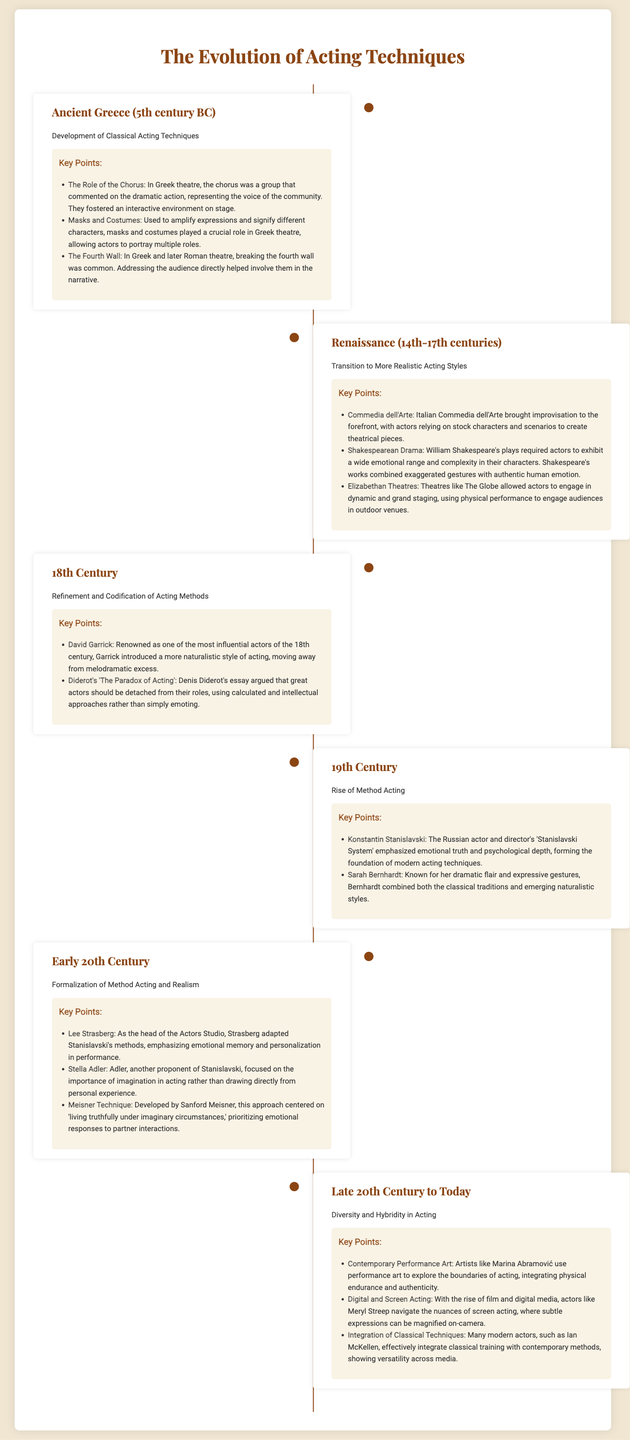What period marks the beginning of Classical Acting Techniques? The document states that Classical Acting Techniques began in Ancient Greece during the 5th century BC.
Answer: 5th century BC Who was a significant figure in the 18th century for introducing a naturalistic acting style? David Garrick is mentioned in the document as one of the most influential actors of the 18th century for his naturalistic style.
Answer: David Garrick Which acting technique focuses on emotional truth and psychological depth? The document identifies the 'Stanislavski System' created by Konstantin Stanislavski as focusing on emotional truth and psychological depth.
Answer: Stanislavski System What decade does the document reference when discussing the rise of Method Acting? The rise of Method Acting is associated with the 19th century in the document.
Answer: 19th century In which division of the timeline is the 'Meisner Technique' mentioned? The 'Meisner Technique' is discussed in the Early 20th Century section of the document.
Answer: Early 20th Century What is the primary characteristic of acting according to Stella Adler? Stella Adler emphasized the importance of imagination in acting, as stated in the document.
Answer: Imagination How does the document describe contemporary performance artists like Marina Abramović? The document describes contemporary performance artists as exploring the boundaries of acting, integrating physical endurance and authenticity.
Answer: Physical endurance and authenticity Which famous actress is noted for navigating the nuances of screen acting? The document highlights Meryl Streep as an example of an actress who navigates screen acting nuances.
Answer: Meryl Streep What term is used to describe the interaction style in Ancient Greece theatre? The document mentions that the chorus represented the voice of the community, fostering an interactive environment.
Answer: Interactive environment 